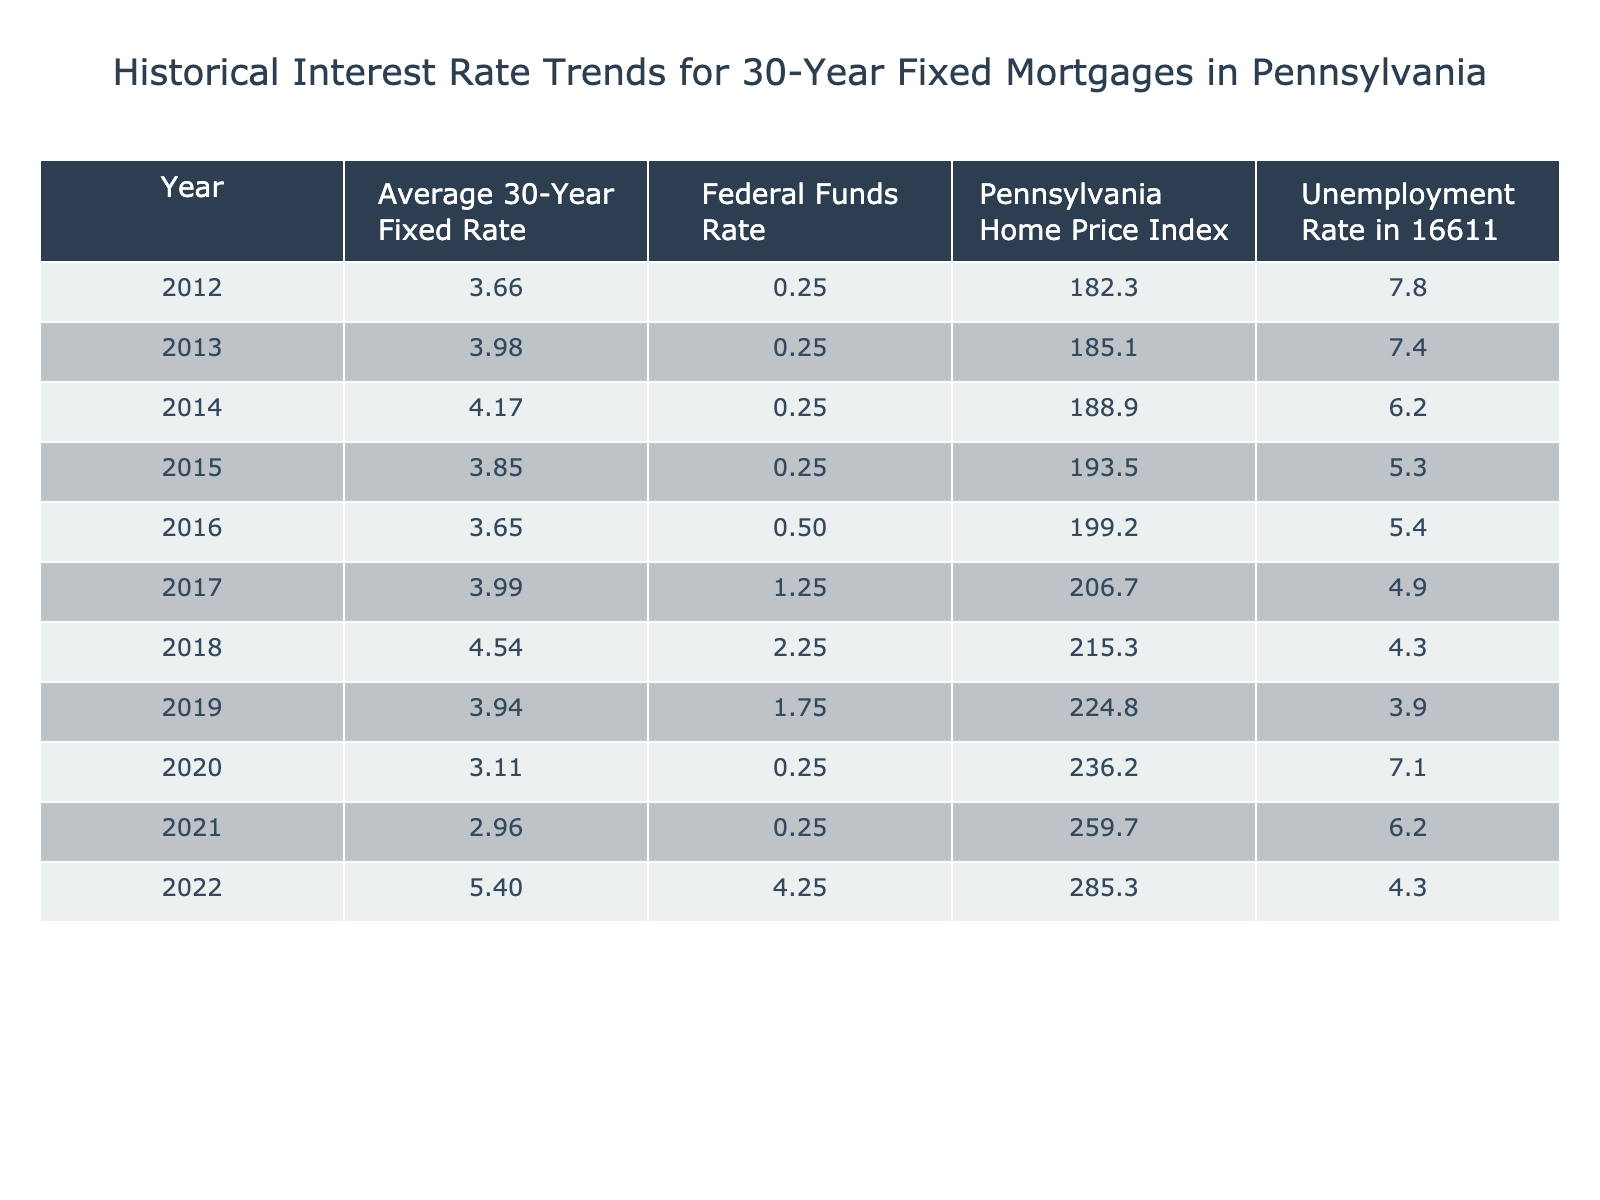What was the average 30-year fixed mortgage rate in 2021? From the table, the entry for the year 2021 shows that the average 30-year fixed mortgage rate was 2.96%.
Answer: 2.96% What was the Federal Funds Rate in 2018? Looking at the table for the year 2018, the Federal Funds Rate is listed as 2.25%.
Answer: 2.25% In which year did the unemployment rate in 16611 reach its lowest point? Checking the unemployment rate for each year, the lowest rate of 3.9% occurred in 2019.
Answer: 2019 What is the difference between the average mortgage rate in 2022 and 2019? The average mortgage rate in 2022 is 5.40% and in 2019 it is 3.94%. The difference is 5.40% - 3.94% = 1.46%.
Answer: 1.46% Was the Federal Funds Rate higher in 2022 than in 2020? In 2022, the Federal Funds Rate was 4.25%, while in 2020 it was 0.25%. Since 4.25% is greater than 0.25%, the statement is true.
Answer: Yes What trend can be observed about the average mortgage rates from 2012 to 2022? By examining the values, we can see that mortgage rates generally declined from 2012 (3.66%) to 2021 (2.96%), then sharply increased to 5.40% in 2022. This indicates a recent upward trend after a long-term decline.
Answer: Decline followed by an increase Calculate the average unemployment rate over the years provided in the table. The unemployment rates for the years are: 7.8%, 7.4%, 6.2%, 5.3%, 5.4%, 4.9%, 4.3%, 3.9%, 7.1%, 6.2%, and 4.3%. The sum of these rates is 60.5%, and there are 11 years. So, the average is 60.5% / 11 ≈ 5.50%.
Answer: 5.50% How did the Pennsylvania Home Price Index change from 2012 to 2022? The index started at 182.3 in 2012 and increased to 285.3 in 2022. Therefore, it shows a steady increase over the period. The increase is 285.3 - 182.3 = 103.0.
Answer: Increased by 103.0 Is it true that the unemployment rate decreased every year from 2012 to 2019? Evaluating the unemployment rates, while there was a general downward trend, in 2020 the rate increased to 7.1% before declining again in 2021. Therefore, it is not true that it decreased every year.
Answer: No What was the highest average 30-year fixed mortgage rate in the table? Looking through the years, the highest average rate listed is 5.40% in 2022.
Answer: 5.40% Calculate the percentage increase in the Pennsylvania Home Price Index from 2015 to 2022. In 2015, the index was 193.5, and in 2022, it is 285.3. The increase is 285.3 - 193.5 = 91.8. The percentage increase is (91.8 / 193.5) * 100 ≈ 47.4%.
Answer: 47.4% 